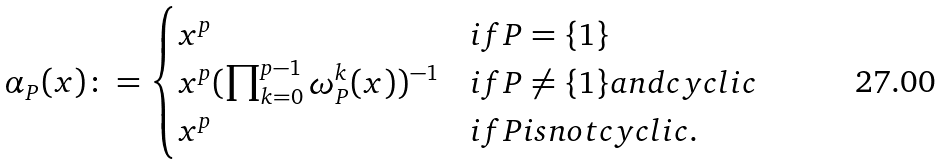<formula> <loc_0><loc_0><loc_500><loc_500>\alpha _ { P } ( x ) \colon = \begin{cases} x ^ { p } & i f P = \{ 1 \} \\ x ^ { p } ( \prod _ { k = 0 } ^ { p - 1 } \omega _ { P } ^ { k } ( x ) ) ^ { - 1 } & i f P \neq \{ 1 \} a n d c y c l i c \\ x ^ { p } & i f P i s n o t c y c l i c . \end{cases}</formula> 